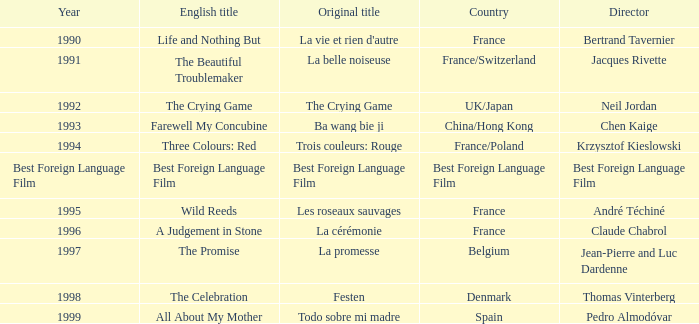Which Year has the Orginal title of La Cérémonie? 1996.0. 